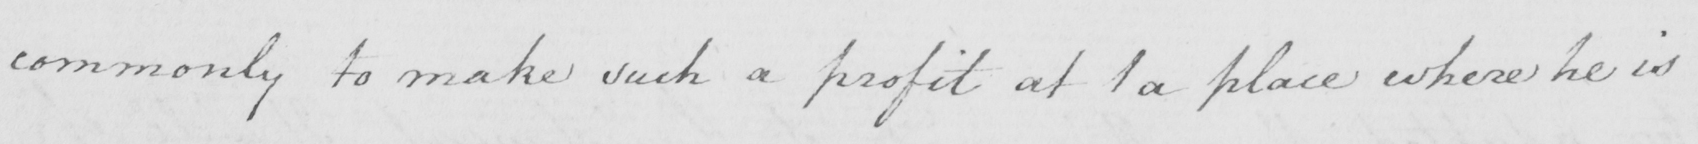Can you read and transcribe this handwriting? commonly to make such a profit at 1 a place where he is 